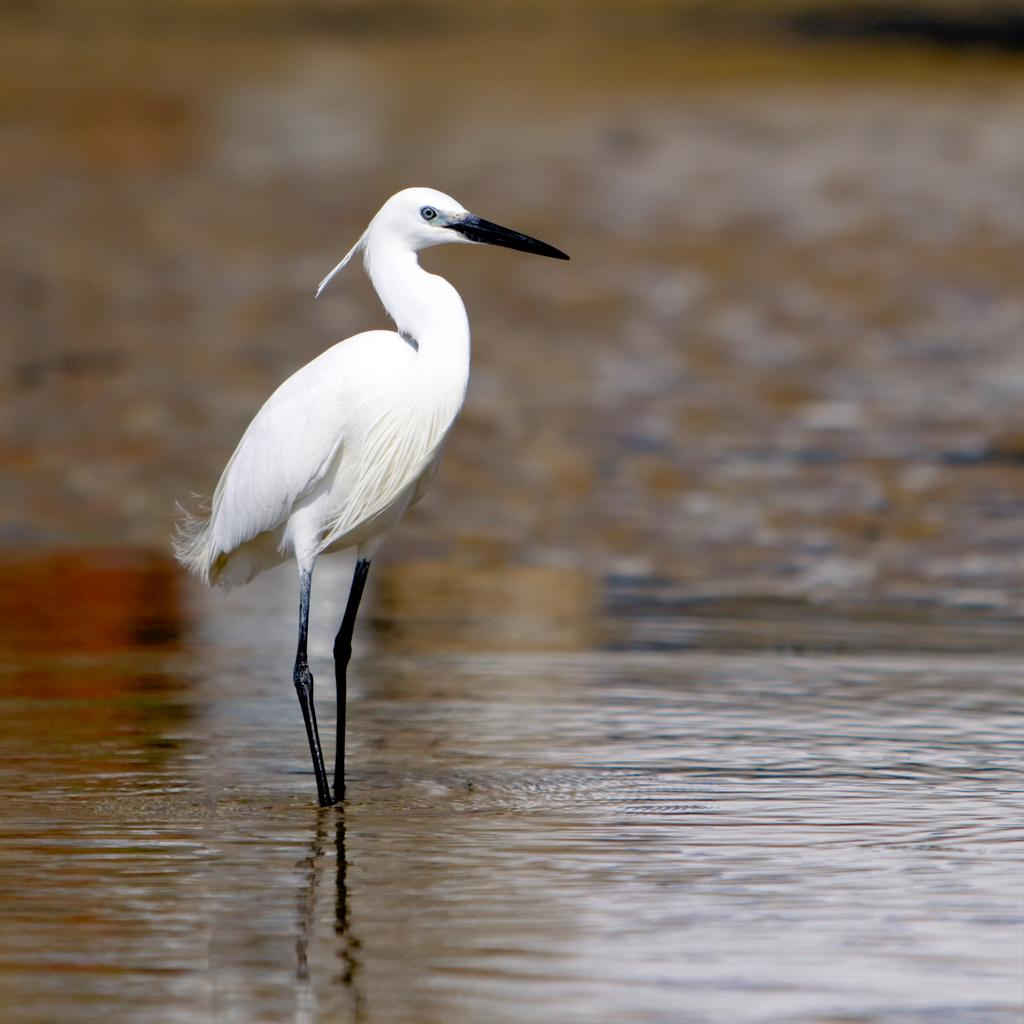What is the primary element in the picture? There is water in the picture. What type of animal can be seen in the image? There is a white color bird in the picture. Where is the bird positioned in the image? The bird is in front of the image. How would you describe the background of the image? The background is blurred. What type of rice can be seen floating in the water in the image? There is no rice present in the image; it only features water and a bird. How does the sponge contribute to the image's aesthetic? There is no sponge present in the image, so it cannot contribute to the image's aesthetic. 